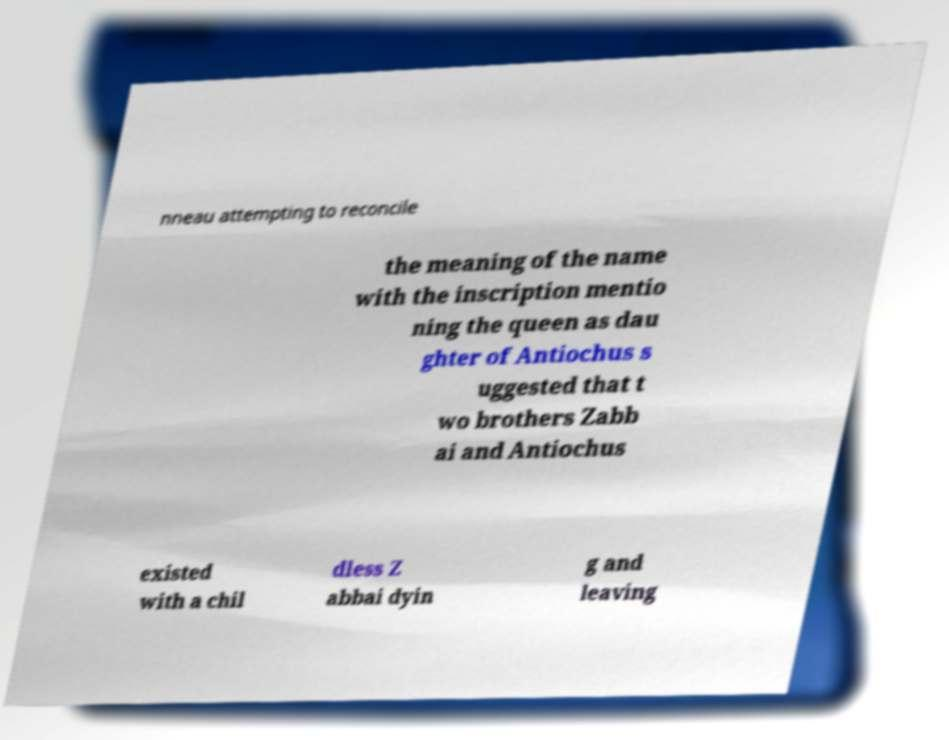I need the written content from this picture converted into text. Can you do that? nneau attempting to reconcile the meaning of the name with the inscription mentio ning the queen as dau ghter of Antiochus s uggested that t wo brothers Zabb ai and Antiochus existed with a chil dless Z abbai dyin g and leaving 